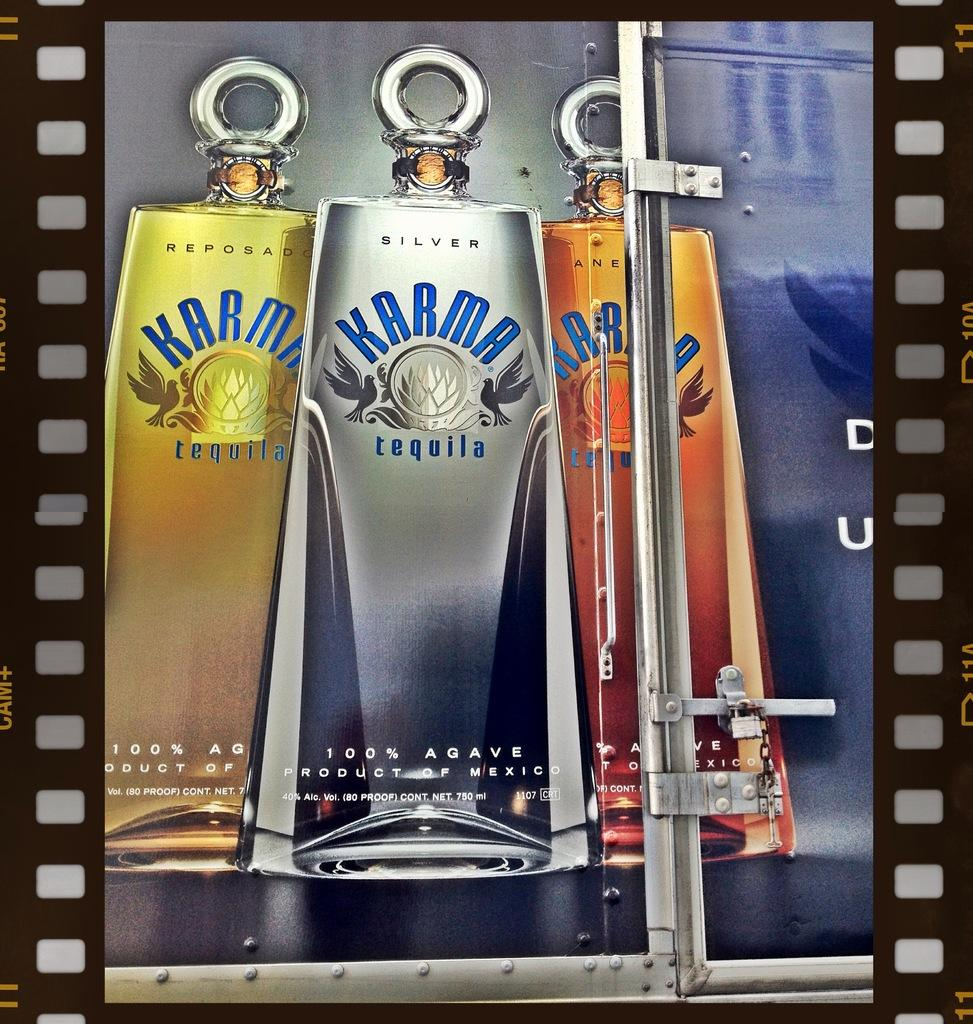What objects are present in the image? There are bottles in the image. What is inside the bottles? The bottles contain text. What type of pail is used by the spy to hide the pen in the image? There is no pail, spy, or pen present in the image. 